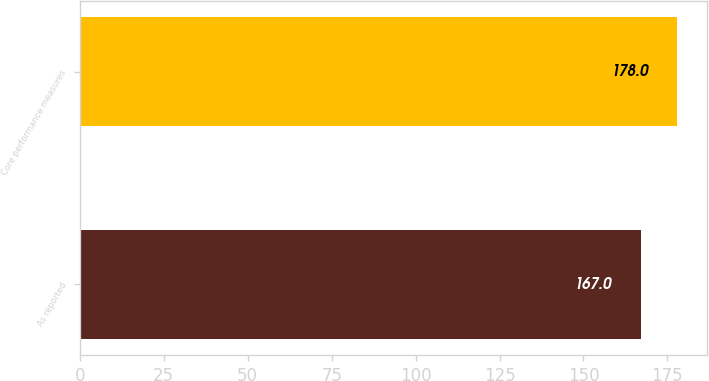Convert chart to OTSL. <chart><loc_0><loc_0><loc_500><loc_500><bar_chart><fcel>As reported<fcel>Core performance measures<nl><fcel>167<fcel>178<nl></chart> 